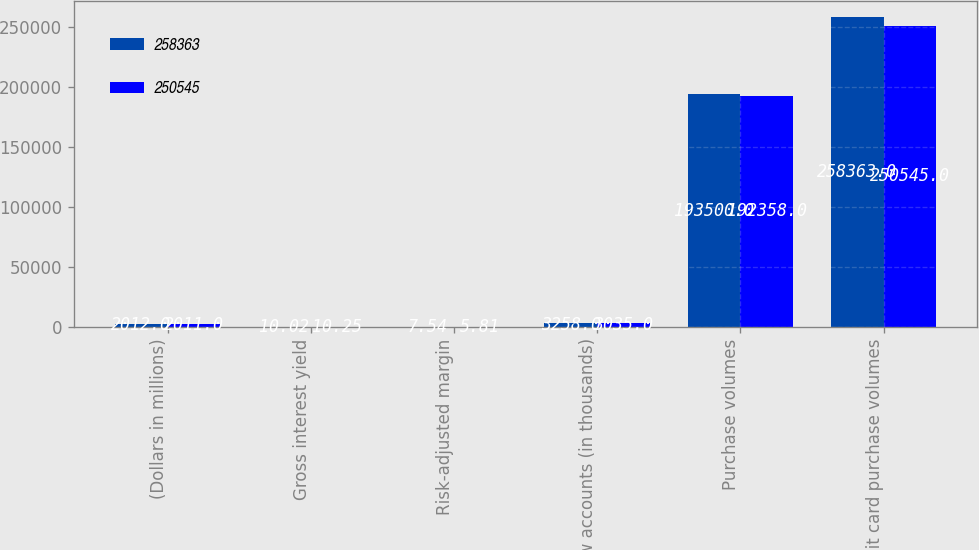<chart> <loc_0><loc_0><loc_500><loc_500><stacked_bar_chart><ecel><fcel>(Dollars in millions)<fcel>Gross interest yield<fcel>Risk-adjusted margin<fcel>New accounts (in thousands)<fcel>Purchase volumes<fcel>Debit card purchase volumes<nl><fcel>258363<fcel>2012<fcel>10.02<fcel>7.54<fcel>3258<fcel>193500<fcel>258363<nl><fcel>250545<fcel>2011<fcel>10.25<fcel>5.81<fcel>3035<fcel>192358<fcel>250545<nl></chart> 